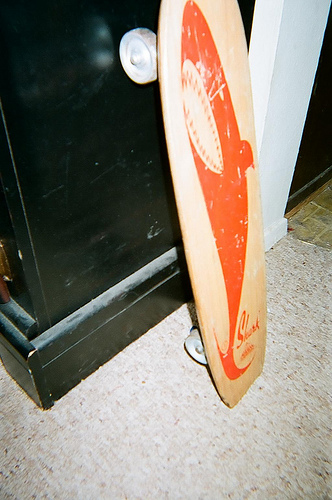<image>
Is there a shark in front of the cabinet? Yes. The shark is positioned in front of the cabinet, appearing closer to the camera viewpoint. 